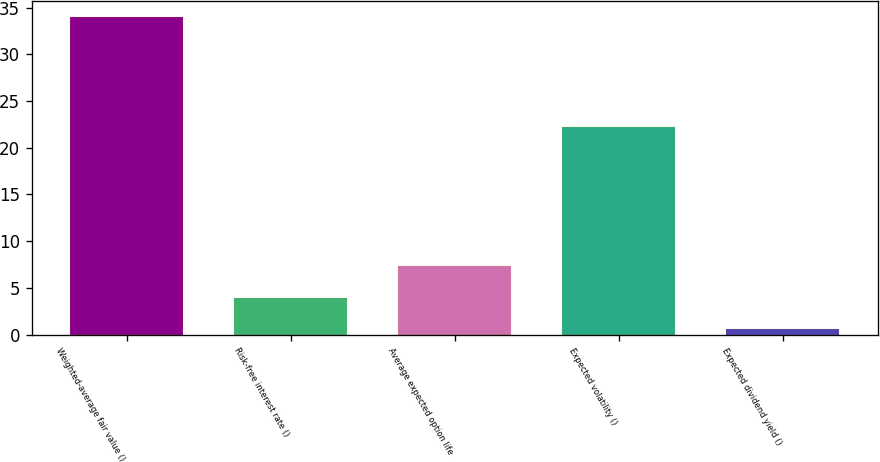Convert chart to OTSL. <chart><loc_0><loc_0><loc_500><loc_500><bar_chart><fcel>Weighted-average fair value ()<fcel>Risk-free interest rate ()<fcel>Average expected option life<fcel>Expected volatility ()<fcel>Expected dividend yield ()<nl><fcel>33.98<fcel>3.96<fcel>7.3<fcel>22.17<fcel>0.62<nl></chart> 